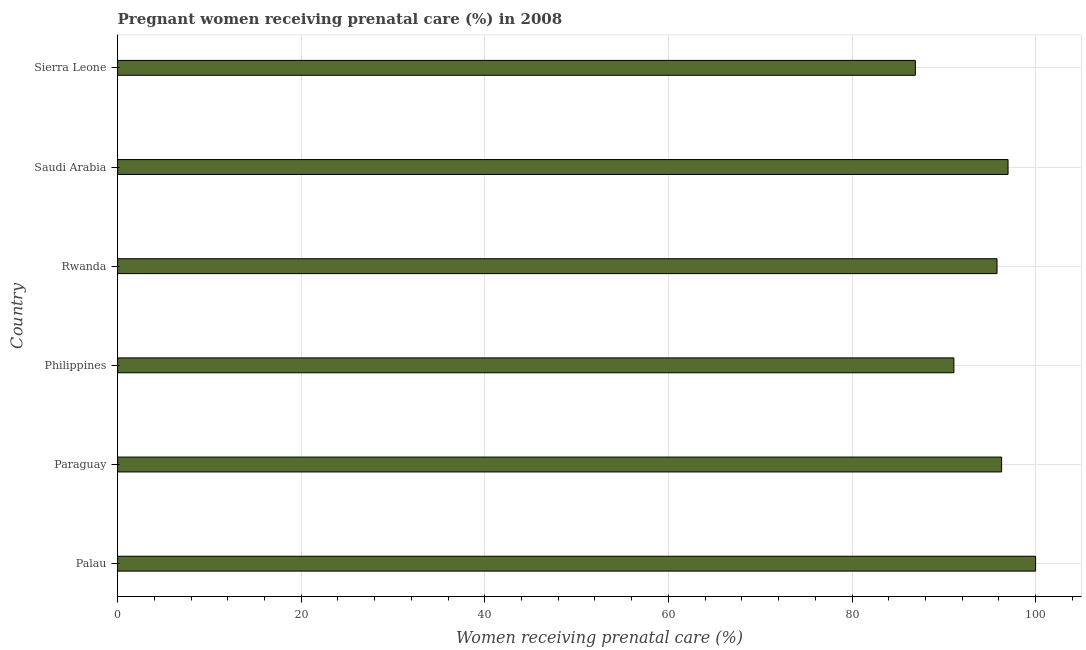What is the title of the graph?
Give a very brief answer. Pregnant women receiving prenatal care (%) in 2008. What is the label or title of the X-axis?
Your answer should be compact. Women receiving prenatal care (%). What is the label or title of the Y-axis?
Provide a succinct answer. Country. What is the percentage of pregnant women receiving prenatal care in Rwanda?
Keep it short and to the point. 95.8. Across all countries, what is the minimum percentage of pregnant women receiving prenatal care?
Provide a short and direct response. 86.9. In which country was the percentage of pregnant women receiving prenatal care maximum?
Offer a very short reply. Palau. In which country was the percentage of pregnant women receiving prenatal care minimum?
Your answer should be compact. Sierra Leone. What is the sum of the percentage of pregnant women receiving prenatal care?
Your answer should be compact. 567.1. What is the average percentage of pregnant women receiving prenatal care per country?
Offer a terse response. 94.52. What is the median percentage of pregnant women receiving prenatal care?
Ensure brevity in your answer.  96.05. What is the ratio of the percentage of pregnant women receiving prenatal care in Rwanda to that in Sierra Leone?
Your answer should be compact. 1.1. What is the difference between the highest and the second highest percentage of pregnant women receiving prenatal care?
Offer a very short reply. 3. Is the sum of the percentage of pregnant women receiving prenatal care in Rwanda and Sierra Leone greater than the maximum percentage of pregnant women receiving prenatal care across all countries?
Give a very brief answer. Yes. How many bars are there?
Your answer should be compact. 6. What is the difference between two consecutive major ticks on the X-axis?
Your response must be concise. 20. What is the Women receiving prenatal care (%) in Paraguay?
Make the answer very short. 96.3. What is the Women receiving prenatal care (%) in Philippines?
Provide a short and direct response. 91.1. What is the Women receiving prenatal care (%) of Rwanda?
Offer a terse response. 95.8. What is the Women receiving prenatal care (%) in Saudi Arabia?
Offer a terse response. 97. What is the Women receiving prenatal care (%) in Sierra Leone?
Your response must be concise. 86.9. What is the difference between the Women receiving prenatal care (%) in Paraguay and Rwanda?
Make the answer very short. 0.5. What is the difference between the Women receiving prenatal care (%) in Paraguay and Saudi Arabia?
Provide a succinct answer. -0.7. What is the difference between the Women receiving prenatal care (%) in Philippines and Saudi Arabia?
Provide a short and direct response. -5.9. What is the difference between the Women receiving prenatal care (%) in Philippines and Sierra Leone?
Provide a short and direct response. 4.2. What is the difference between the Women receiving prenatal care (%) in Saudi Arabia and Sierra Leone?
Make the answer very short. 10.1. What is the ratio of the Women receiving prenatal care (%) in Palau to that in Paraguay?
Your answer should be very brief. 1.04. What is the ratio of the Women receiving prenatal care (%) in Palau to that in Philippines?
Ensure brevity in your answer.  1.1. What is the ratio of the Women receiving prenatal care (%) in Palau to that in Rwanda?
Give a very brief answer. 1.04. What is the ratio of the Women receiving prenatal care (%) in Palau to that in Saudi Arabia?
Your answer should be compact. 1.03. What is the ratio of the Women receiving prenatal care (%) in Palau to that in Sierra Leone?
Ensure brevity in your answer.  1.15. What is the ratio of the Women receiving prenatal care (%) in Paraguay to that in Philippines?
Give a very brief answer. 1.06. What is the ratio of the Women receiving prenatal care (%) in Paraguay to that in Sierra Leone?
Provide a short and direct response. 1.11. What is the ratio of the Women receiving prenatal care (%) in Philippines to that in Rwanda?
Provide a succinct answer. 0.95. What is the ratio of the Women receiving prenatal care (%) in Philippines to that in Saudi Arabia?
Keep it short and to the point. 0.94. What is the ratio of the Women receiving prenatal care (%) in Philippines to that in Sierra Leone?
Provide a short and direct response. 1.05. What is the ratio of the Women receiving prenatal care (%) in Rwanda to that in Saudi Arabia?
Provide a succinct answer. 0.99. What is the ratio of the Women receiving prenatal care (%) in Rwanda to that in Sierra Leone?
Provide a short and direct response. 1.1. What is the ratio of the Women receiving prenatal care (%) in Saudi Arabia to that in Sierra Leone?
Your answer should be compact. 1.12. 